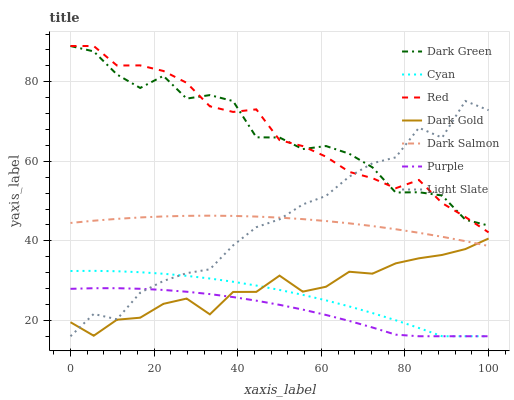Does Purple have the minimum area under the curve?
Answer yes or no. Yes. Does Red have the maximum area under the curve?
Answer yes or no. Yes. Does Dark Salmon have the minimum area under the curve?
Answer yes or no. No. Does Dark Salmon have the maximum area under the curve?
Answer yes or no. No. Is Dark Salmon the smoothest?
Answer yes or no. Yes. Is Dark Green the roughest?
Answer yes or no. Yes. Is Purple the smoothest?
Answer yes or no. No. Is Purple the roughest?
Answer yes or no. No. Does Purple have the lowest value?
Answer yes or no. Yes. Does Dark Salmon have the lowest value?
Answer yes or no. No. Does Dark Green have the highest value?
Answer yes or no. Yes. Does Dark Salmon have the highest value?
Answer yes or no. No. Is Cyan less than Red?
Answer yes or no. Yes. Is Dark Green greater than Purple?
Answer yes or no. Yes. Does Light Slate intersect Dark Gold?
Answer yes or no. Yes. Is Light Slate less than Dark Gold?
Answer yes or no. No. Is Light Slate greater than Dark Gold?
Answer yes or no. No. Does Cyan intersect Red?
Answer yes or no. No. 